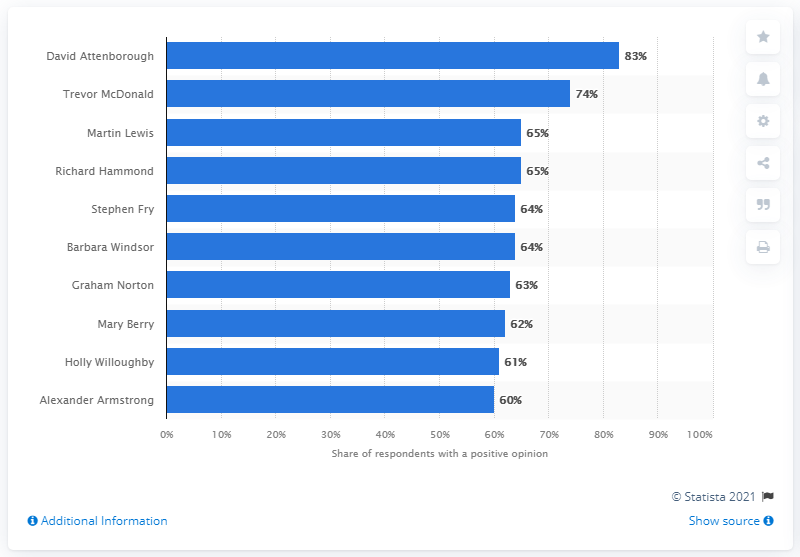Identify some key points in this picture. In 2021, David Attenborough was the highest ranked TV personality in the UK. 